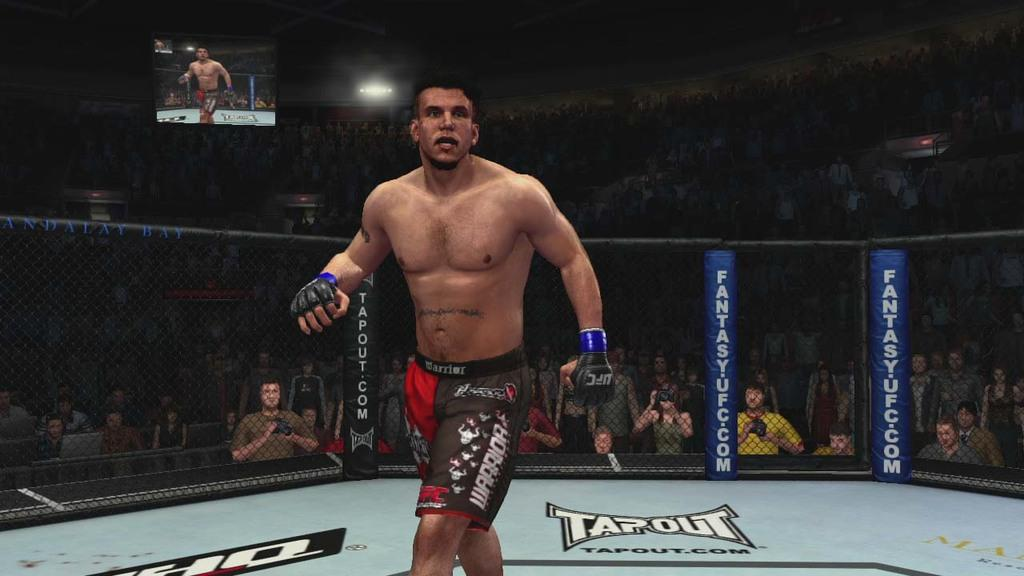<image>
Give a short and clear explanation of the subsequent image. a boxer in a boxing ring that says 'tapout' on it 